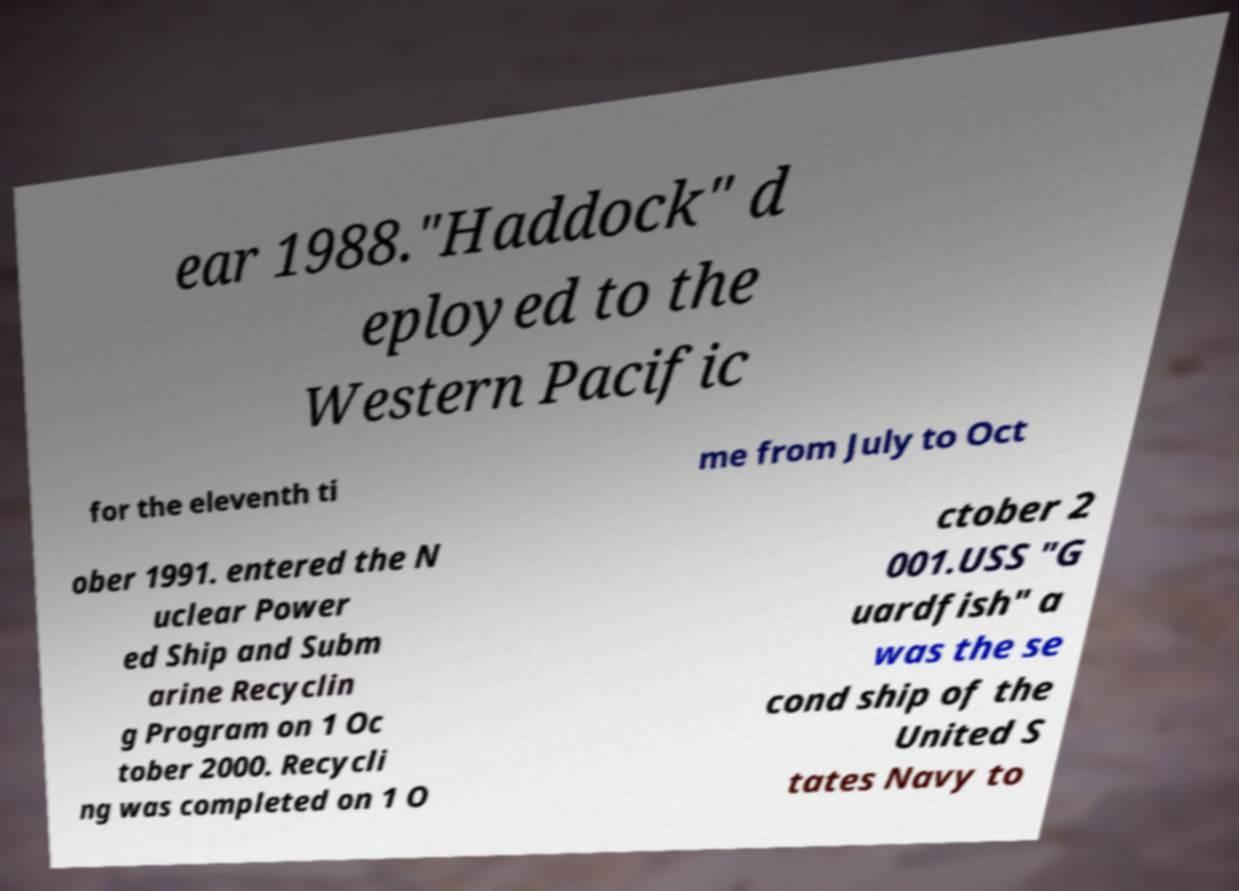Can you accurately transcribe the text from the provided image for me? ear 1988."Haddock" d eployed to the Western Pacific for the eleventh ti me from July to Oct ober 1991. entered the N uclear Power ed Ship and Subm arine Recyclin g Program on 1 Oc tober 2000. Recycli ng was completed on 1 O ctober 2 001.USS "G uardfish" a was the se cond ship of the United S tates Navy to 